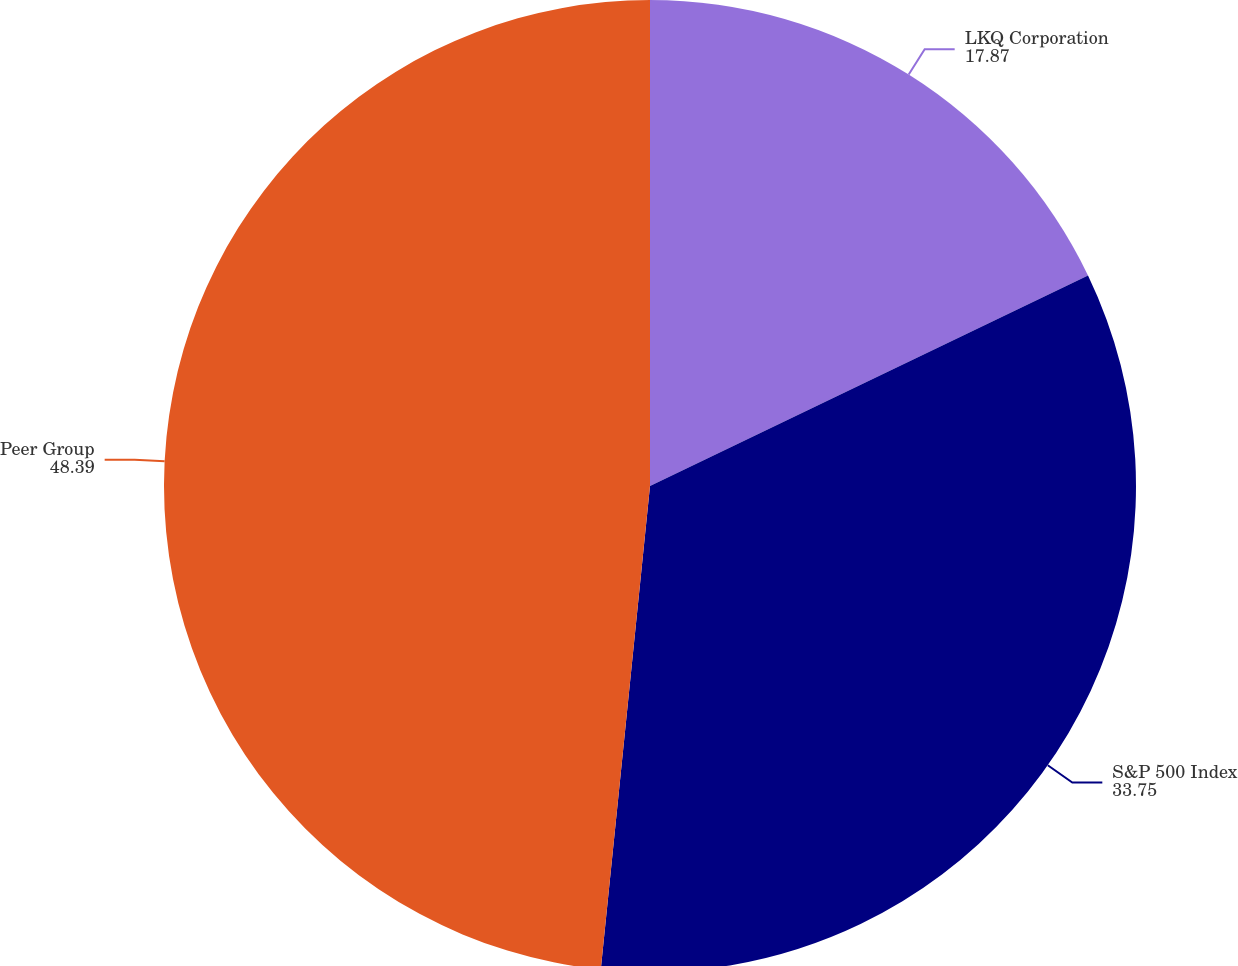<chart> <loc_0><loc_0><loc_500><loc_500><pie_chart><fcel>LKQ Corporation<fcel>S&P 500 Index<fcel>Peer Group<nl><fcel>17.87%<fcel>33.75%<fcel>48.39%<nl></chart> 